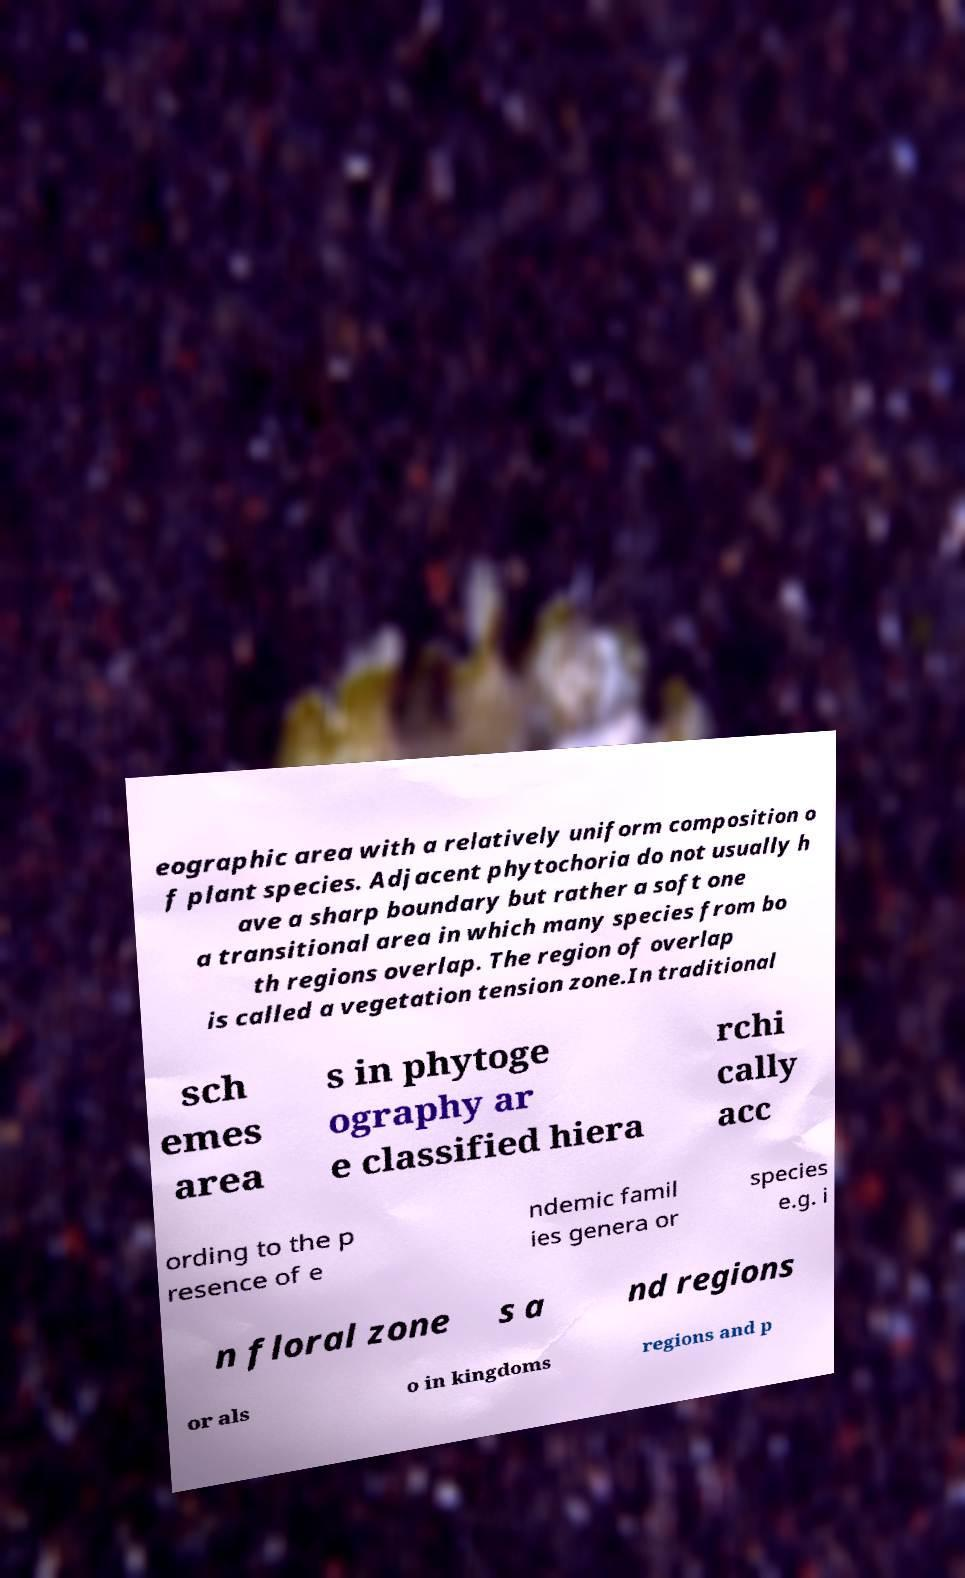Could you assist in decoding the text presented in this image and type it out clearly? eographic area with a relatively uniform composition o f plant species. Adjacent phytochoria do not usually h ave a sharp boundary but rather a soft one a transitional area in which many species from bo th regions overlap. The region of overlap is called a vegetation tension zone.In traditional sch emes area s in phytoge ography ar e classified hiera rchi cally acc ording to the p resence of e ndemic famil ies genera or species e.g. i n floral zone s a nd regions or als o in kingdoms regions and p 